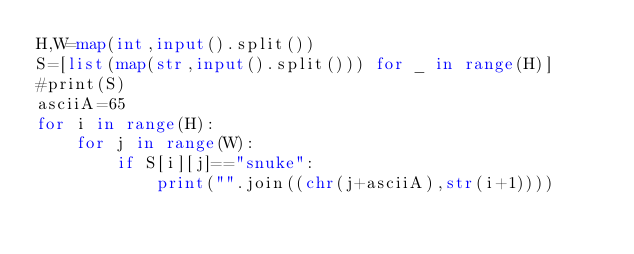<code> <loc_0><loc_0><loc_500><loc_500><_Python_>H,W=map(int,input().split())
S=[list(map(str,input().split())) for _ in range(H)]
#print(S)
asciiA=65
for i in range(H):
    for j in range(W):
        if S[i][j]=="snuke":
            print("".join((chr(j+asciiA),str(i+1))))</code> 